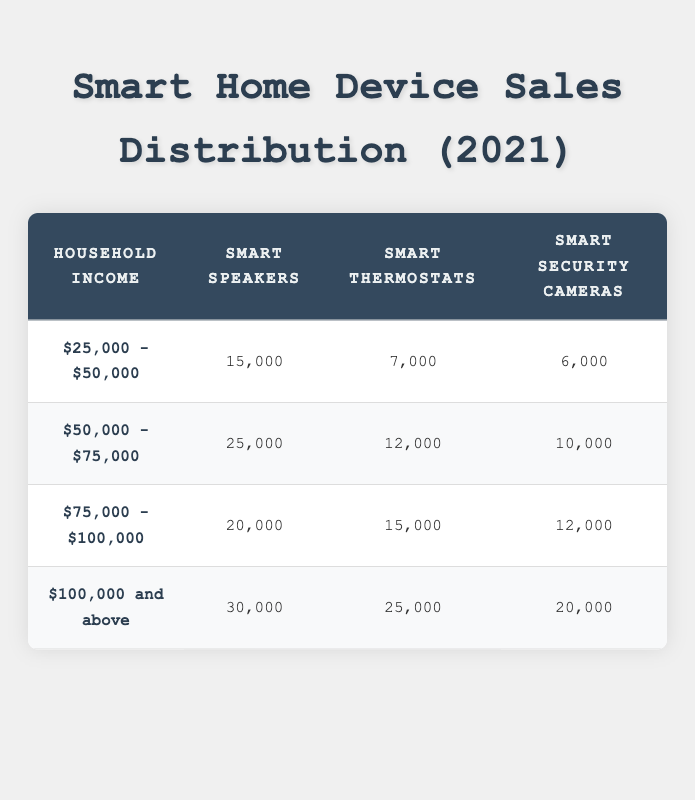What is the total number of Smart Thermostats sold in households earning between $25,000 and $75,000? To find the total, we need to sum the units sold for Smart Thermostats within the income ranges of $25,000 - $50,000 and $50,000 - $75,000. From the table, we see 7,000 units sold for the first range and 12,000 for the second. Therefore, the total is 7,000 + 12,000 = 19,000.
Answer: 19,000 Which device type had the highest sales among households earning $100,000 and above? The highest sales for the income group of $100,000 and above can be found by comparing the units sold of all device types in that row. Smart Speakers had 30,000 units, Smart Thermostats had 25,000 units, and Smart Security Cameras had 20,000 units. 30,000 is the highest value.
Answer: Smart Speakers True or False: More Smart Security Cameras were sold in the $50,000 - $75,000 income category than in the $25,000 - $50,000 category. To evaluate this, we can directly compare the units sold in both income brackets. In the $50,000 - $75,000 category, 10,000 units were sold, while in the $25,000 - $50,000 category, 6,000 units were sold. Since 10,000 is greater than 6,000, the statement is true.
Answer: True What is the average number of Smart Speakers sold across all income brackets? To find the average, we first sum the total units sold for Smart Speakers across all income brackets: 15,000 + 25,000 + 20,000 + 30,000 = 90,000. There are four income brackets, so we divide this total by 4. Therefore, the average is 90,000 / 4 = 22,500.
Answer: 22,500 Which device sold the least number of units in the $25,000 - $50,000 income category? We can look at the row corresponding to the $25,000 - $50,000 income range and check the units sold for each device type: Smart Speakers (15,000), Smart Thermostats (7,000), and Smart Security Cameras (6,000). The least number among these is 6,000 for Smart Security Cameras.
Answer: Smart Security Cameras 